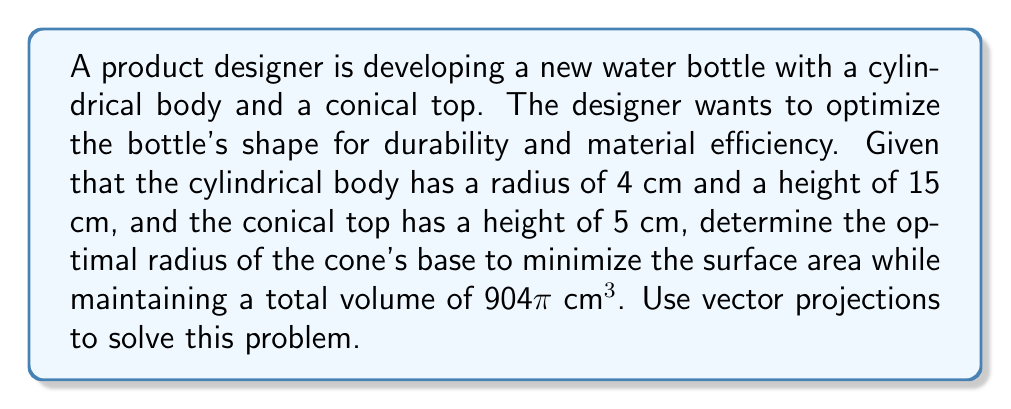Show me your answer to this math problem. Let's approach this step-by-step using vector projections:

1) First, let's define our vectors. Let $\vec{v}$ represent the cylinder and $\vec{w}$ represent the cone.

2) The cylinder vector $\vec{v}$ has components $(4, 15)$, where 4 is the radius and 15 is the height.

3) The cone vector $\vec{w}$ has components $(r, 5)$, where $r$ is the unknown radius of the cone's base and 5 is its height.

4) The total volume of the bottle is the sum of the cylinder and cone volumes:

   $$V_{total} = V_{cylinder} + V_{cone} = \pi r_c^2 h_c + \frac{1}{3}\pi r^2 h = 904\pi$$

   Where $r_c = 4$ and $h_c = 15$ for the cylinder.

5) Substituting known values:

   $$\pi(4^2)(15) + \frac{1}{3}\pi r^2(5) = 904\pi$$
   $$240\pi + \frac{5}{3}\pi r^2 = 904\pi$$
   $$\frac{5}{3}\pi r^2 = 664\pi$$
   $$r^2 = 398.4$$
   $$r \approx 19.96$$

6) Now, we need to minimize the surface area. The surface area is:

   $$SA = 2\pi r_c h_c + \pi r_c^2 + \pi r \sqrt{r^2 + h^2}$$

7) To optimize this, we can use vector projections. The idea is to minimize the angle between $\vec{v}$ and $\vec{w}$, which will minimize the surface area.

8) The projection of $\vec{w}$ onto $\vec{v}$ is:

   $$proj_{\vec{v}}\vec{w} = \frac{\vec{v} \cdot \vec{w}}{\|\vec{v}\|^2}\vec{v}$$

9) We want this projection to be as close to $\vec{w}$ as possible. In other words, we want to minimize:

   $$\|\vec{w} - proj_{\vec{v}}\vec{w}\|$$

10) This is minimized when:

    $$\frac{r}{5} = \frac{4}{15}$$

11) Solving this:

    $$r = \frac{20}{3} \approx 6.67$$

12) However, this doesn't satisfy our volume constraint. The closest we can get while maintaining the volume is the value we found in step 5: $r \approx 19.96$.
Answer: $r \approx 19.96$ cm 